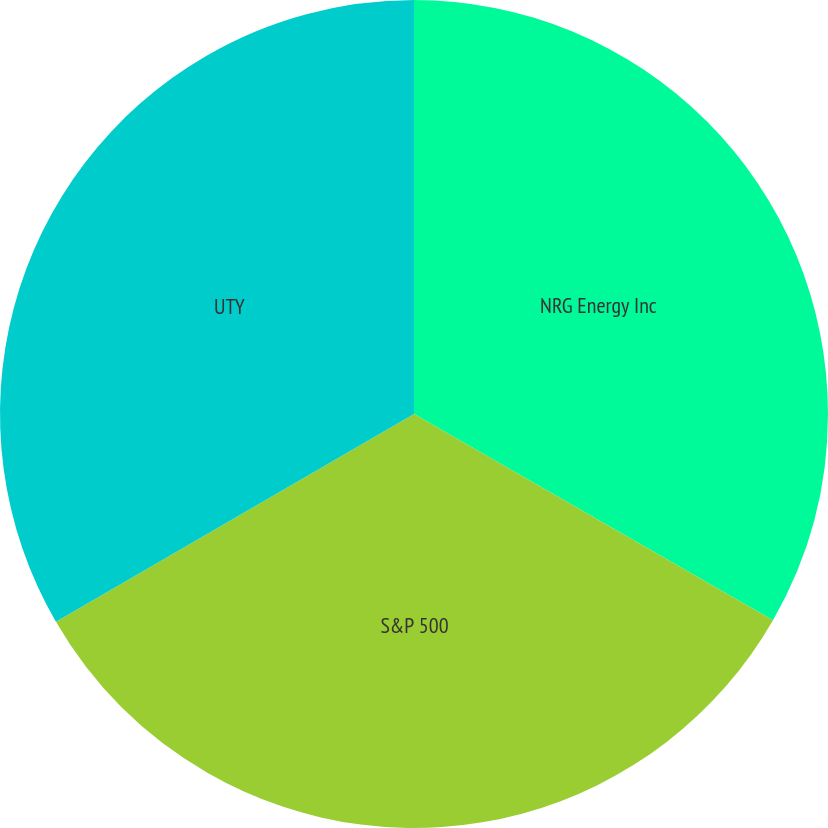Convert chart to OTSL. <chart><loc_0><loc_0><loc_500><loc_500><pie_chart><fcel>NRG Energy Inc<fcel>S&P 500<fcel>UTY<nl><fcel>33.3%<fcel>33.33%<fcel>33.37%<nl></chart> 